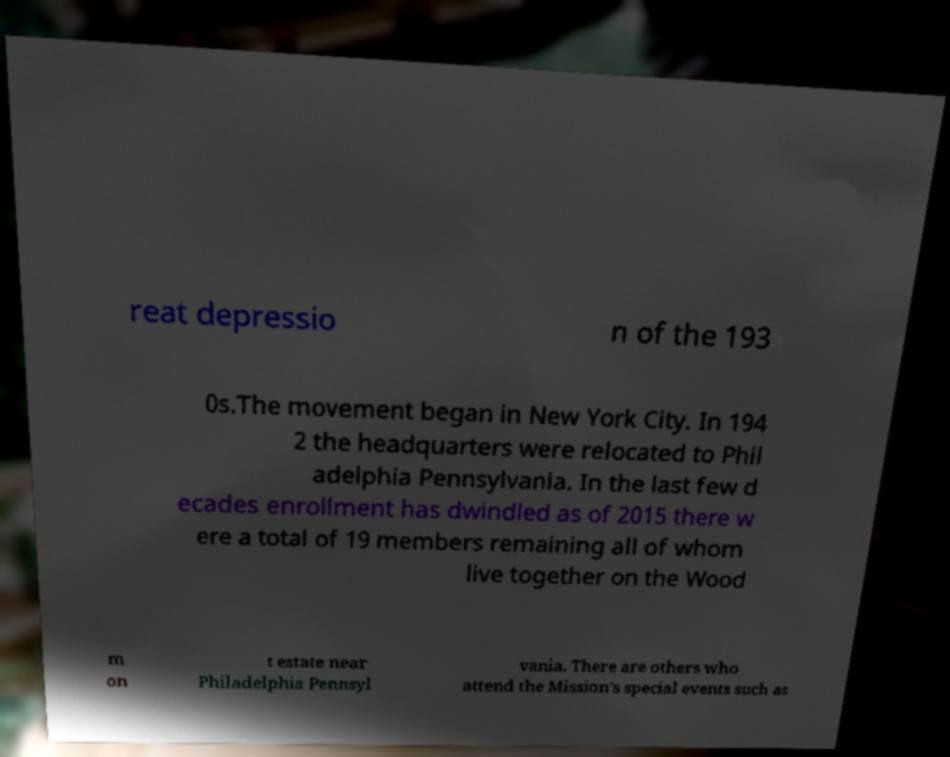Can you read and provide the text displayed in the image?This photo seems to have some interesting text. Can you extract and type it out for me? reat depressio n of the 193 0s.The movement began in New York City. In 194 2 the headquarters were relocated to Phil adelphia Pennsylvania. In the last few d ecades enrollment has dwindled as of 2015 there w ere a total of 19 members remaining all of whom live together on the Wood m on t estate near Philadelphia Pennsyl vania. There are others who attend the Mission's special events such as 